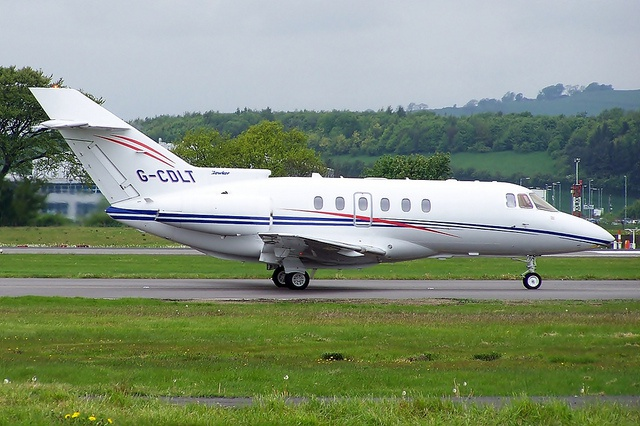Describe the objects in this image and their specific colors. I can see a airplane in lightgray, white, darkgray, gray, and black tones in this image. 